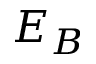Convert formula to latex. <formula><loc_0><loc_0><loc_500><loc_500>E _ { B }</formula> 